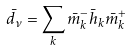Convert formula to latex. <formula><loc_0><loc_0><loc_500><loc_500>\bar { d } _ { \nu } = \sum _ { k } \bar { m } ^ { - } _ { k } \bar { h } _ { k } \bar { m } ^ { + } _ { k }</formula> 